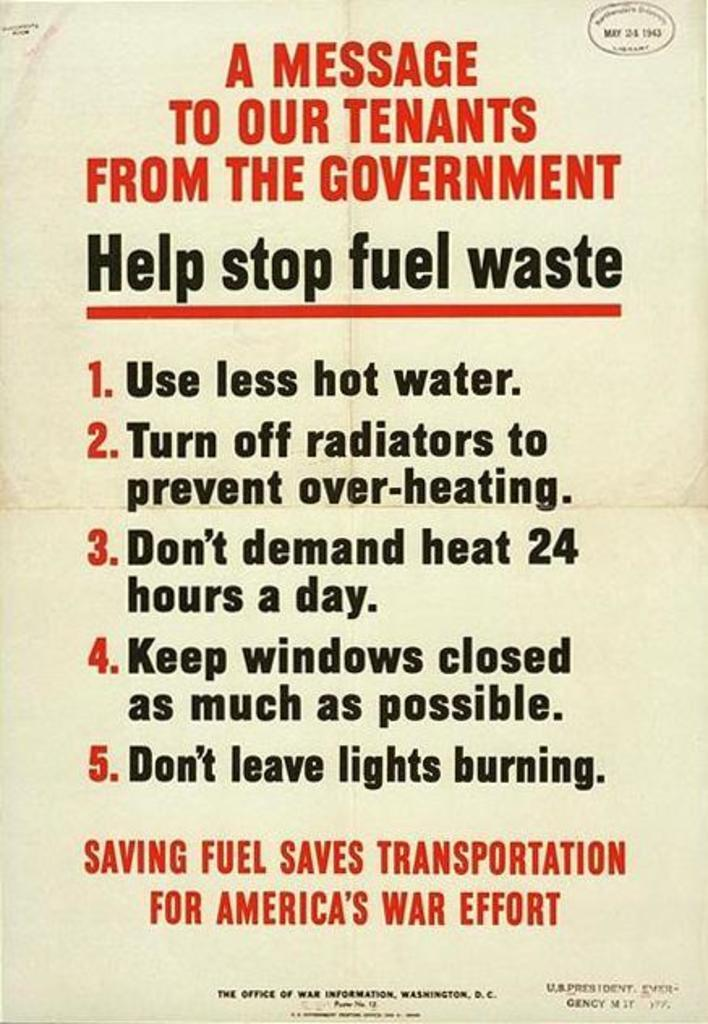Provide a one-sentence caption for the provided image. A message to tenants from the government to help stop fuel waste. 